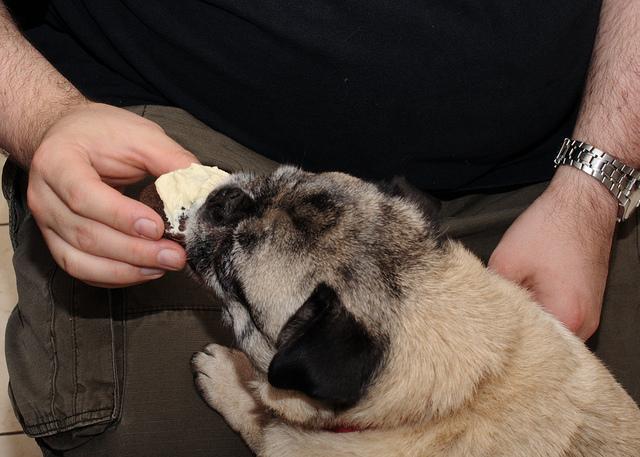What kind of dog is this?
Be succinct. Pug. What is the color of the person's pants?
Short answer required. Brown. What is being fed to the dog?
Concise answer only. Cupcake. 